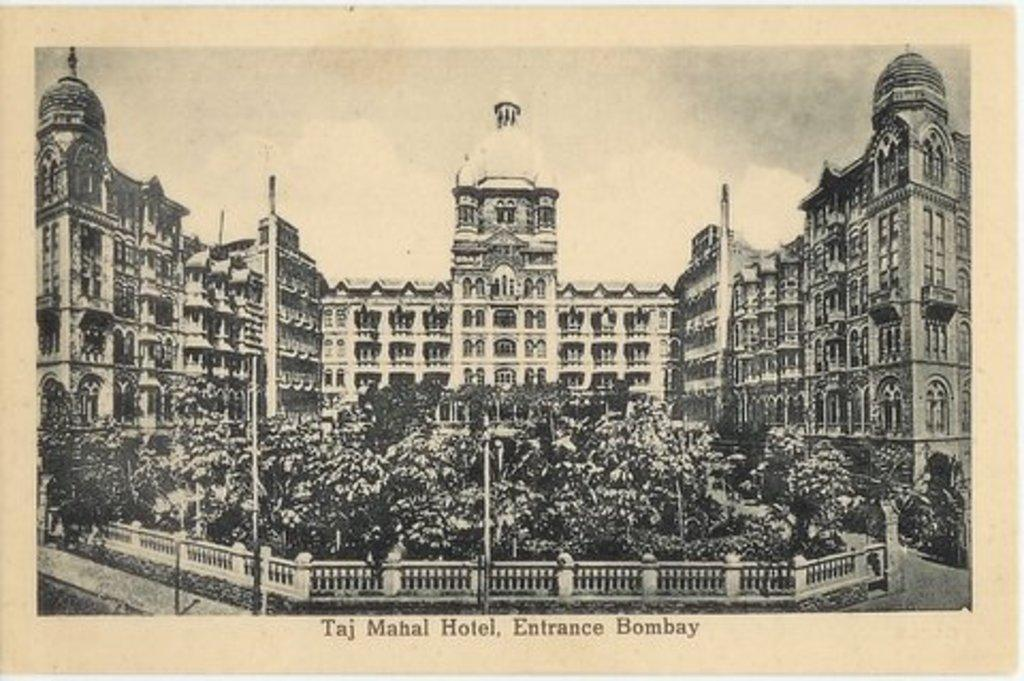<image>
Present a compact description of the photo's key features. A black and white drawing of the Taj Mahal hotel. 